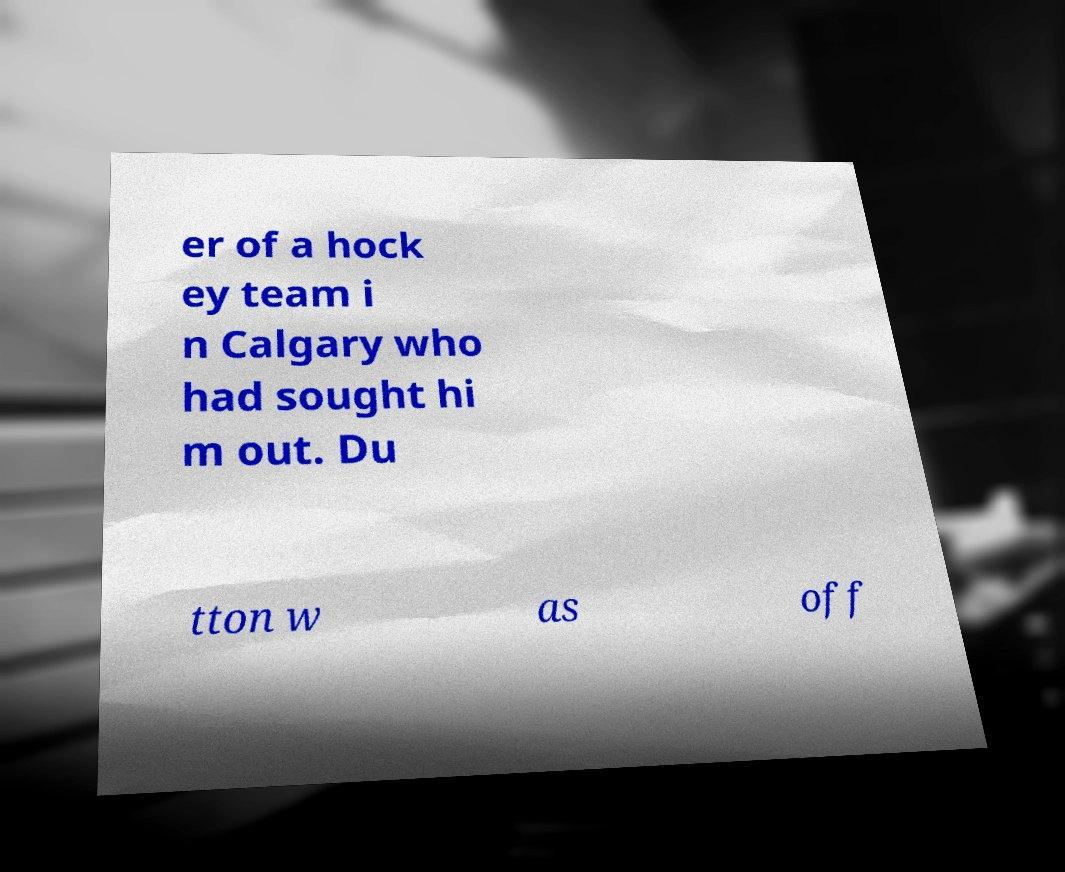Could you assist in decoding the text presented in this image and type it out clearly? er of a hock ey team i n Calgary who had sought hi m out. Du tton w as off 